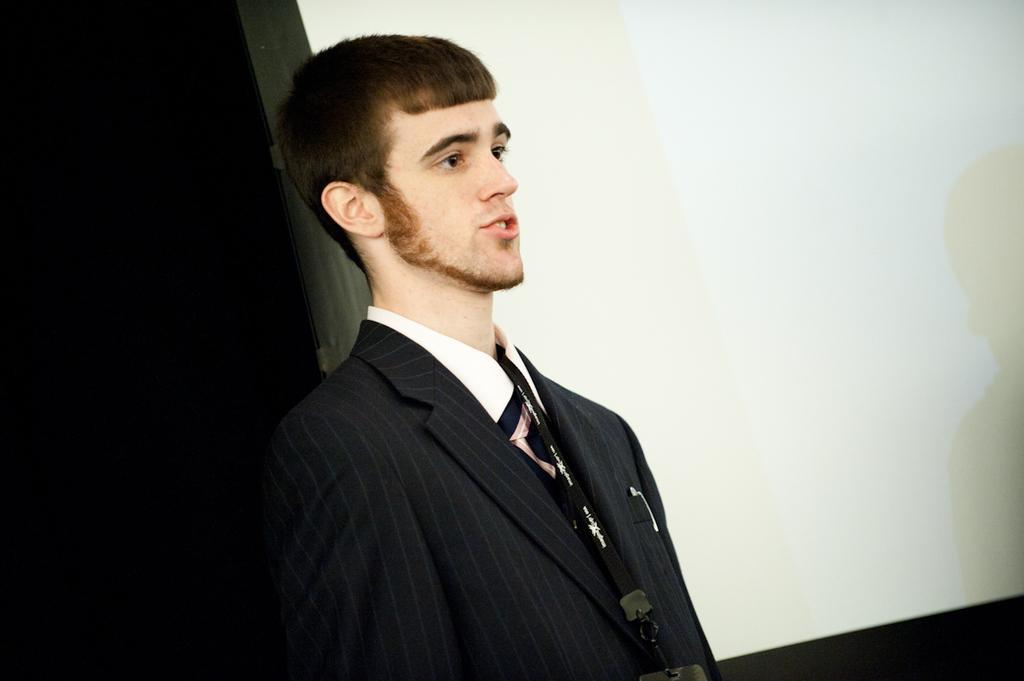Could you give a brief overview of what you see in this image? In the picture I can see a person wearing black blazer, shirt, tie and identity card is standing here. The left side of the image is dark and in the background, I can see the projector screen. 